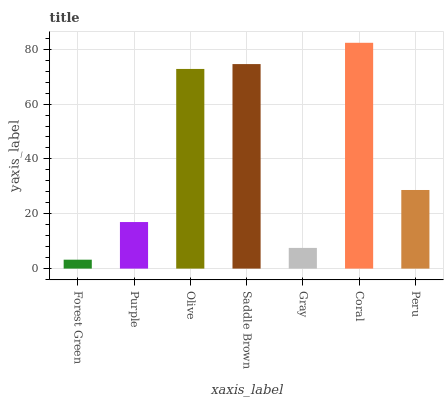Is Forest Green the minimum?
Answer yes or no. Yes. Is Coral the maximum?
Answer yes or no. Yes. Is Purple the minimum?
Answer yes or no. No. Is Purple the maximum?
Answer yes or no. No. Is Purple greater than Forest Green?
Answer yes or no. Yes. Is Forest Green less than Purple?
Answer yes or no. Yes. Is Forest Green greater than Purple?
Answer yes or no. No. Is Purple less than Forest Green?
Answer yes or no. No. Is Peru the high median?
Answer yes or no. Yes. Is Peru the low median?
Answer yes or no. Yes. Is Olive the high median?
Answer yes or no. No. Is Coral the low median?
Answer yes or no. No. 